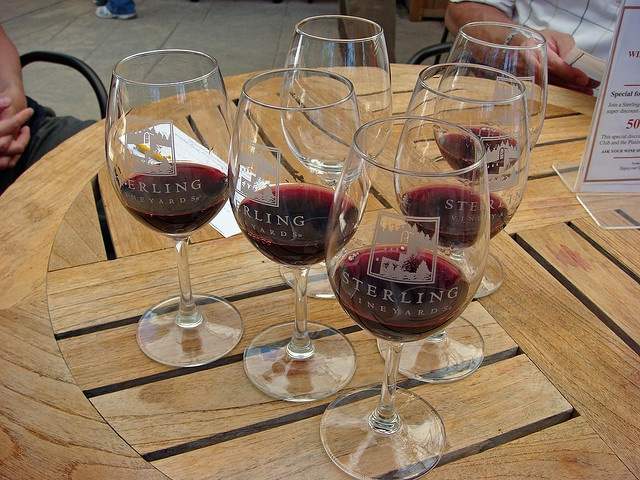Describe the objects in this image and their specific colors. I can see dining table in tan, gray, and black tones, wine glass in gray, tan, black, and maroon tones, wine glass in gray, tan, darkgray, and black tones, wine glass in gray, tan, and darkgray tones, and wine glass in gray, tan, and darkgray tones in this image. 